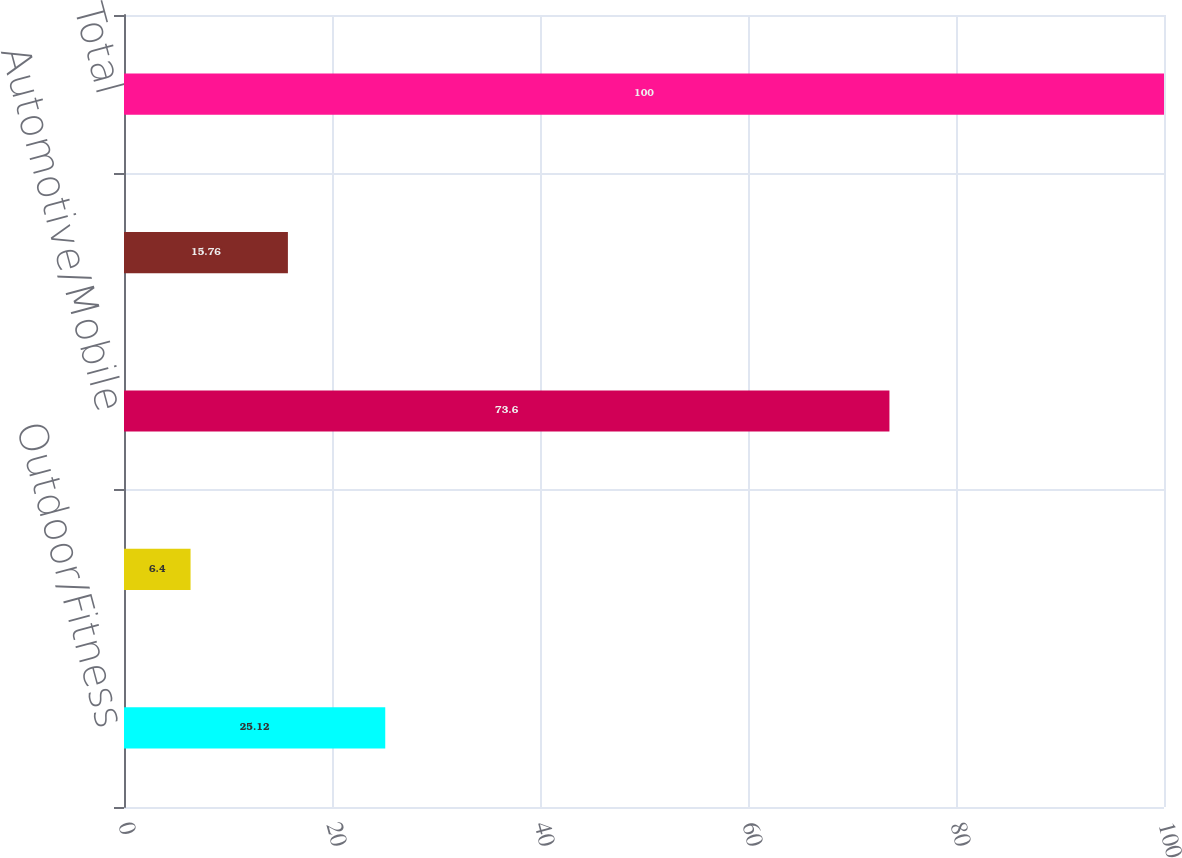<chart> <loc_0><loc_0><loc_500><loc_500><bar_chart><fcel>Outdoor/Fitness<fcel>Marine<fcel>Automotive/Mobile<fcel>Aviation<fcel>Total<nl><fcel>25.12<fcel>6.4<fcel>73.6<fcel>15.76<fcel>100<nl></chart> 